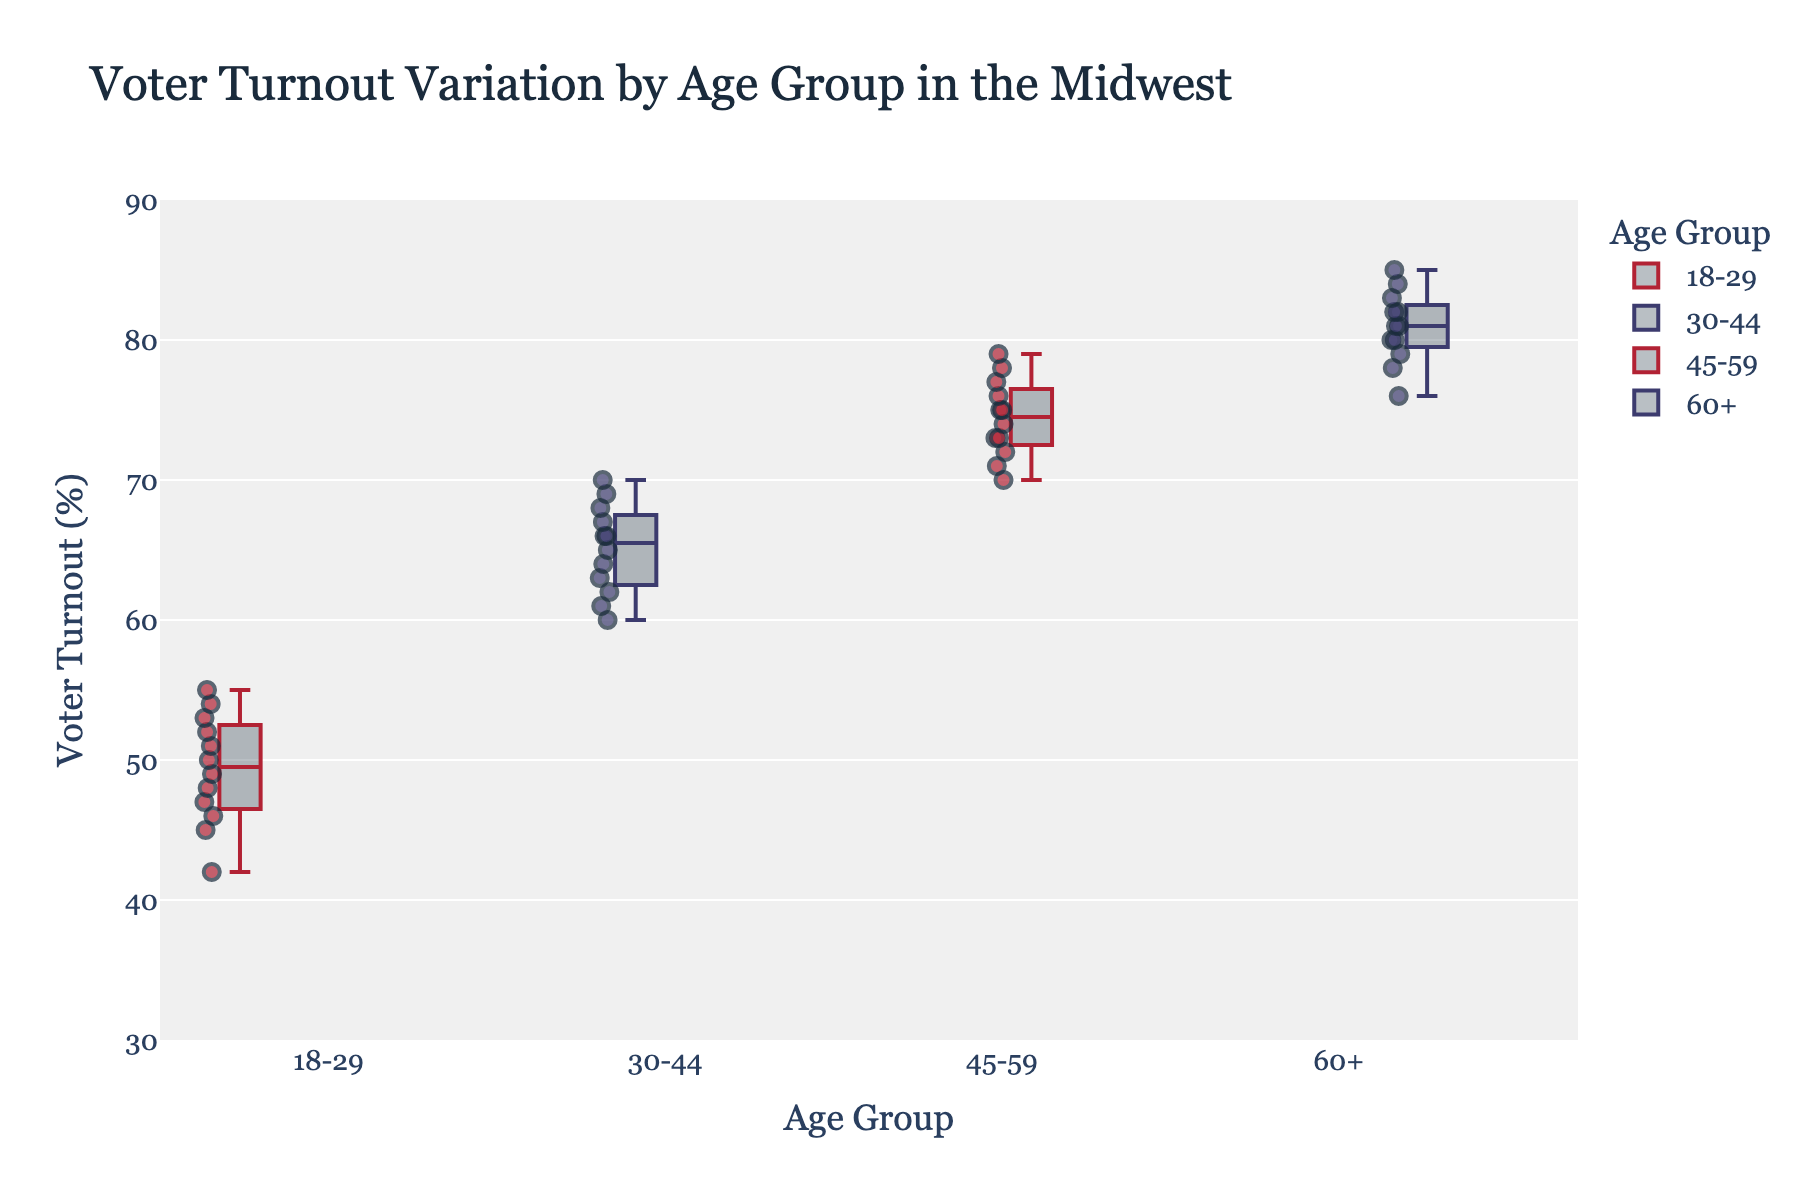What is the title of the plot? The title of the plot is displayed at the top of the box plot and provides a summary of what the plot depicts. Find the text displayed at the top center.
Answer: Voter Turnout Variation by Age Group in the Midwest What is the median voter turnout for the 18-29 age group? The median is the middle value of the voter turnout percentage for the 18-29 age group. The median is shown as a horizontal line inside the box.
Answer: Around 48% Which age group has the highest overall voter turnout? Compare the central tendency (median) of the voter turnout percentages across all age groups and see which box plot has the highest median line.
Answer: 60+ How does voter turnout vary between the 18-29 and 60+ age groups? Look at the spread of data points and the median lines for both age groups to compare their voter turnout distributions. Notice the ranges covered by the box and whiskers.
Answer: The 60+ age group has higher and less variable voter turnout compared to 18-29 What's the interquartile range (IQR) of the voter turnout for the 30-44 age group? The IQR is the range between the 75th percentile (top of the box) and the 25th percentile (bottom of the box). Measure the height of the box for the 30-44 age group.
Answer: About 8% Do any age groups exhibit outliers in voter turnout? Identify any individual points that fall outside the whiskers of the box plots.
Answer: No Which state has the highest voter turnout for the 45-59 age group? Locate the highest individual data point within the 45-59 age group box plot and identify the state from the dataset.
Answer: Wisconsin Compare the range of voter turnout percentages between 45-59 and 30-44 age groups. Analyze the length of the whiskers for both the 45-59 and 30-44 age groups to determine the range of voter turnout percentages. The range is the difference between the highest and lowest points depicted.
Answer: The 45-59 age group has a slightly wider range Are there any age groups where the voter turnout is particularly consistent (low spread)? Consistency is indicated by a smaller interquartile range (IQR) and shorter whiskers, meaning most data points are close to the median line. Look at the box plot shapes to determine which age group has the smallest box and whiskers.
Answer: 60+ What is the overall trend of voter turnout as age increases? Observe the changes in the median lines and the distribution of the voter turnout percentages as you move from younger age groups to older ones.
Answer: Voter turnout increases with age 